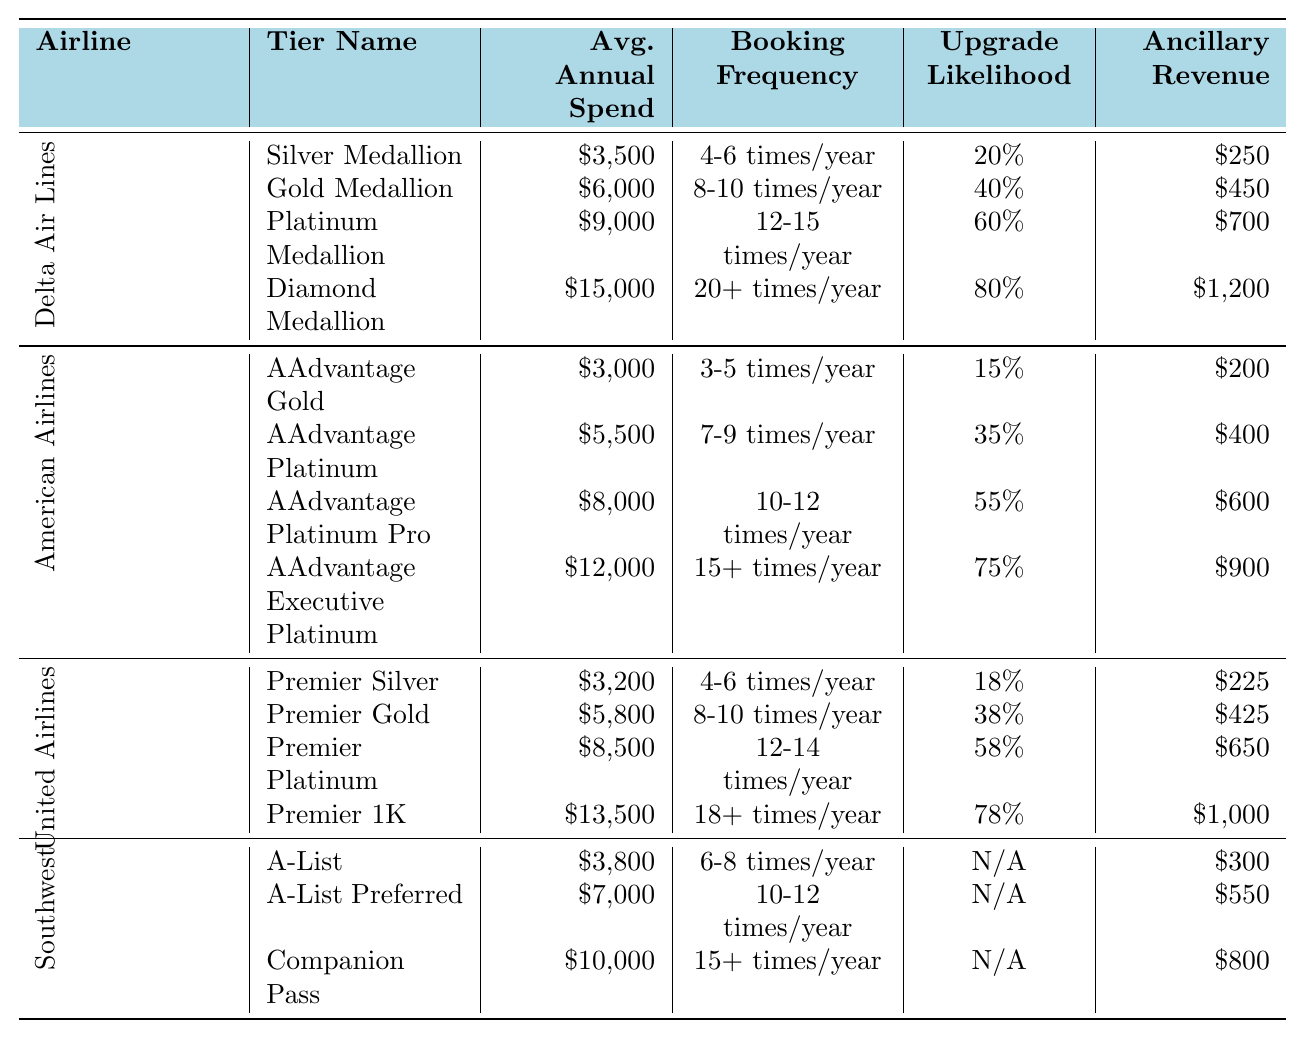What is the average annual spend for the Platinum Medallion tier in Delta Air Lines? According to the table, the average annual spend for the Platinum Medallion tier in Delta Air Lines is listed directly as $9,000.
Answer: $9,000 What is the booking frequency for the AAdvantage Executive Platinum tier in American Airlines? The table indicates that the booking frequency for the AAdvantage Executive Platinum tier in American Airlines is "15+ times/year".
Answer: 15+ times/year Which airline has the highest average annual spend for its loyalty program tiers? To determine this, we can compare the highest average annual spends across all airlines. Delta Air Lines has a Diamond Medallion tier spend of $15,000, American Airlines has $12,000 for its Executive Platinum tier, United Airlines has $13,500 for Premier 1K, and Southwest Airlines has $10,000 for Companion Pass. The highest is $15,000 from Delta Air Lines.
Answer: Delta Air Lines What is the total ancillary revenue for all loyalty program tiers of Southwest Airlines? From the table, the ancillary revenues for Southwest Airlines are $300 for A-List, $550 for A-List Preferred, and $800 for Companion Pass. Adding these together gives $300 + $550 + $800 = $1,650.
Answer: $1,650 Is the upgrade likelihood higher for Gold Medallion in Delta Air Lines than for AAdvantage Gold in American Airlines? The upgrade likelihood for Gold Medallion in Delta Air Lines is 40%, while for AAdvantage Gold in American Airlines it is 15%. Since 40% is greater than 15%, the statement is true.
Answer: Yes What is the difference in average annual spend between the Companion Pass tier in Southwest Airlines and the Diamond Medallion tier in Delta Air Lines? The average annual spend for the Companion Pass in Southwest Airlines is $10,000, and for the Diamond Medallion in Delta Air Lines, it is $15,000. To find the difference, subtract $10,000 from $15,000, resulting in $15,000 - $10,000 = $5,000.
Answer: $5,000 Which tier has a higher booking frequency: Premier Platinum in United Airlines or Gold Medallion in Delta Air Lines? Premier Platinum in United Airlines has a booking frequency of "12-14 times/year", while Gold Medallion in Delta Air Lines is "8-10 times/year". Since "12-14 times" is greater than "8-10 times", Premier Platinum has a higher booking frequency.
Answer: Premier Platinum What is the average annual spend for all tiers in American Airlines combined? The average annual spends for AAdvantage tiers in American Airlines are $3,000, $5,500, $8,000, and $12,000. Summing these gives $3,000 + $5,500 + $8,000 + $12,000 = $28,500, and dividing by the number of tiers (4) gives $28,500 / 4 = $7,125.
Answer: $7,125 Which airline’s loyalty program tier has the highest upgrade likelihood? Reviewing the upgrade likelihoods, Diamond Medallion in Delta Air Lines has an upgrade likelihood of 80%, Executive Platinum in American Airlines has 75%, Premier 1K in United Airlines has 78%, and Southwest Airlines has N/A for its tiers. The highest value is 80% for Diamond Medallion from Delta Air Lines.
Answer: Delta Air Lines If a customer books 10 flights a year with American Airlines' AAdvantage Platinum, what is the expected ancillary revenue from that tier? The ancillary revenue for AAdvantage Platinum in American Airlines is $400 per year, which doesn't depend on the number of flights but rather enhances spending. Thus, if only considering ancillary revenue, it remains $400.
Answer: $400 